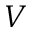<formula> <loc_0><loc_0><loc_500><loc_500>V</formula> 